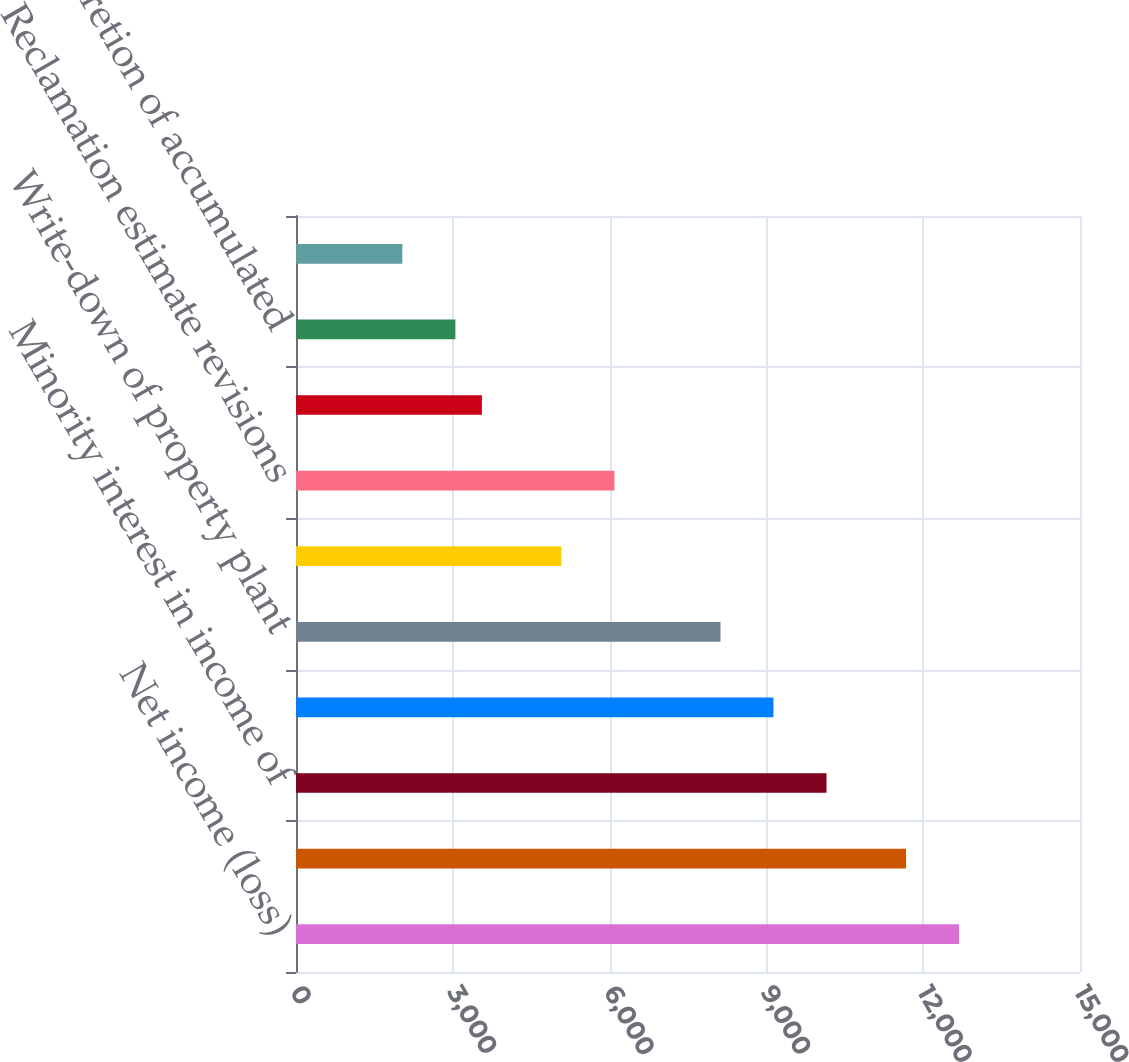<chart> <loc_0><loc_0><loc_500><loc_500><bar_chart><fcel>Net income (loss)<fcel>Amortization<fcel>Minority interest in income of<fcel>Deferred income taxes<fcel>Write-down of property plant<fcel>Gain on asset sales net<fcel>Reclamation estimate revisions<fcel>Stock based compensation and<fcel>Accretion of accumulated<fcel>(Income) loss from<nl><fcel>12686<fcel>11671.6<fcel>10150<fcel>9135.6<fcel>8121.2<fcel>5078<fcel>6092.4<fcel>3556.4<fcel>3049.2<fcel>2034.8<nl></chart> 